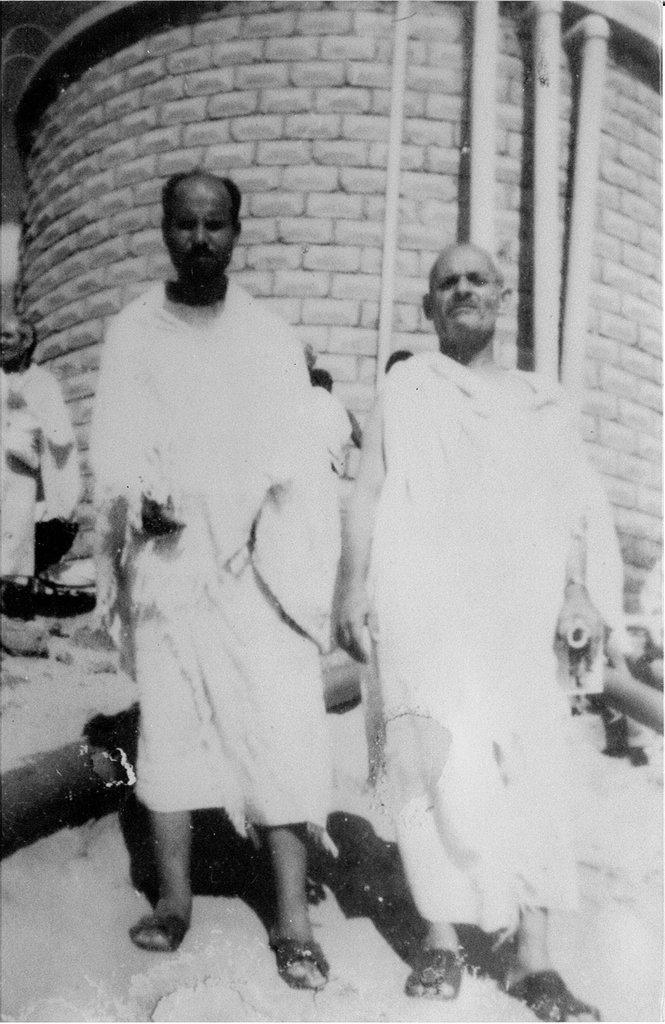What is the color scheme of the image? The image is black and white. What can be seen in the image? There are people in the image. What is visible in the background of the image? There are pipes and a wall in the background of the image. What type of jelly can be seen on the wall in the image? There is no jelly present in the image; it is a black and white image with people and a wall in the background. How many sisters are visible in the image? There is no information about sisters in the image, as it only mentions the presence of people. 